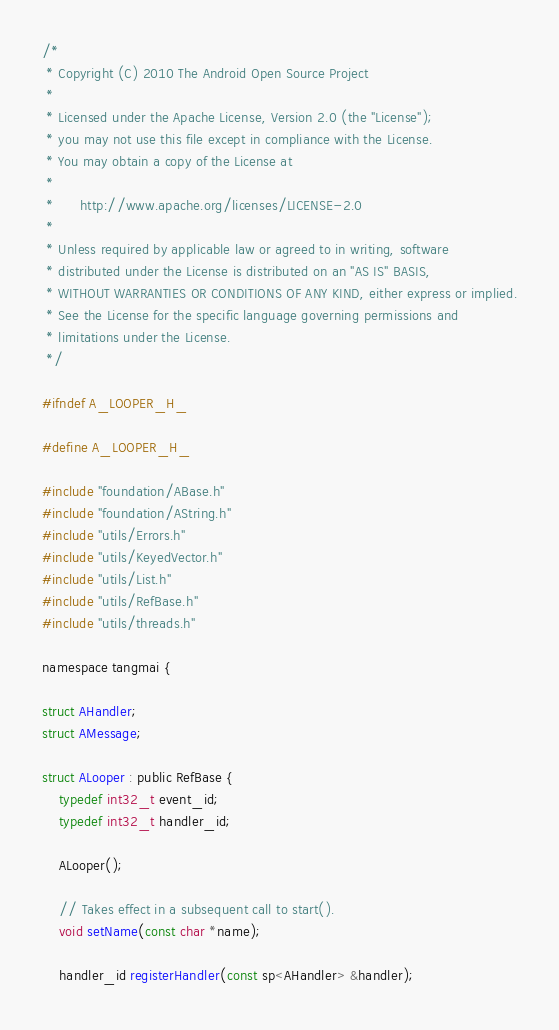Convert code to text. <code><loc_0><loc_0><loc_500><loc_500><_C_>/*
 * Copyright (C) 2010 The Android Open Source Project
 *
 * Licensed under the Apache License, Version 2.0 (the "License");
 * you may not use this file except in compliance with the License.
 * You may obtain a copy of the License at
 *
 *      http://www.apache.org/licenses/LICENSE-2.0
 *
 * Unless required by applicable law or agreed to in writing, software
 * distributed under the License is distributed on an "AS IS" BASIS,
 * WITHOUT WARRANTIES OR CONDITIONS OF ANY KIND, either express or implied.
 * See the License for the specific language governing permissions and
 * limitations under the License.
 */

#ifndef A_LOOPER_H_

#define A_LOOPER_H_

#include "foundation/ABase.h"
#include "foundation/AString.h"
#include "utils/Errors.h"
#include "utils/KeyedVector.h"
#include "utils/List.h"
#include "utils/RefBase.h"
#include "utils/threads.h"

namespace tangmai {

struct AHandler;
struct AMessage;

struct ALooper : public RefBase {
    typedef int32_t event_id;
    typedef int32_t handler_id;

    ALooper();

    // Takes effect in a subsequent call to start().
    void setName(const char *name);

    handler_id registerHandler(const sp<AHandler> &handler);</code> 